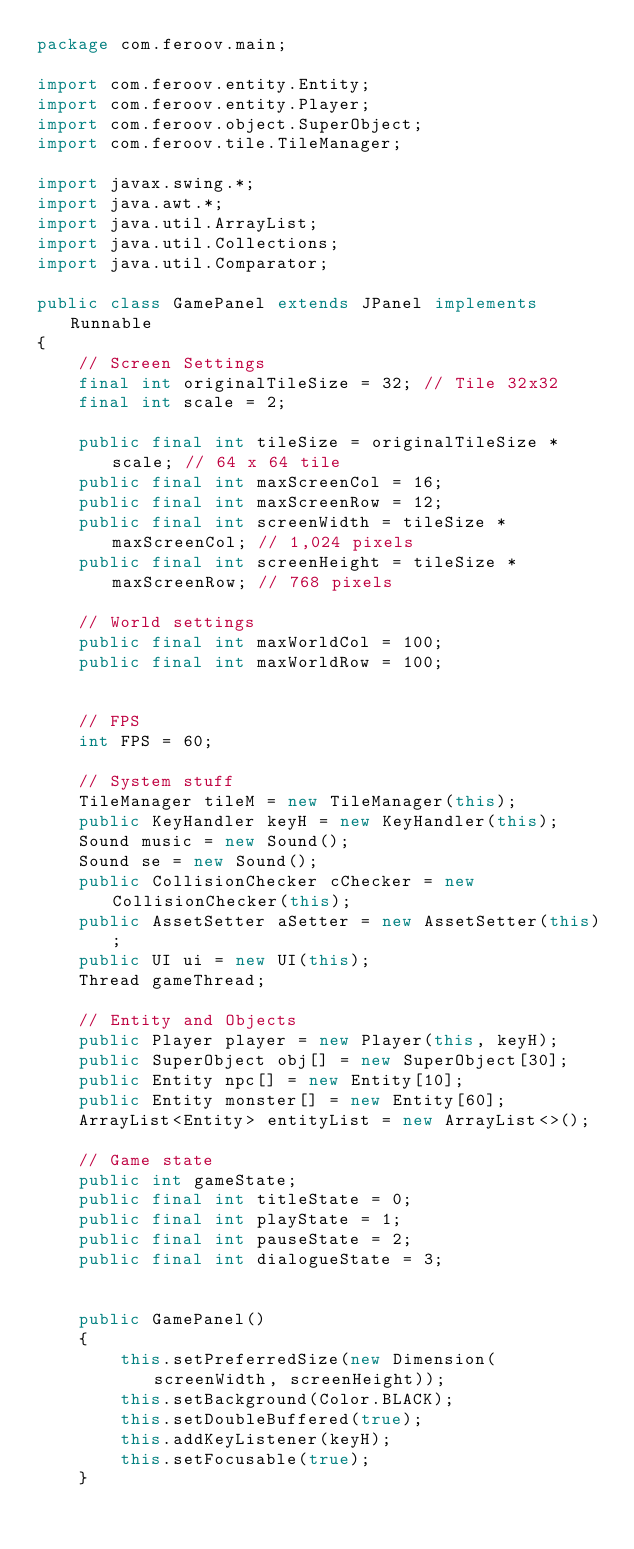Convert code to text. <code><loc_0><loc_0><loc_500><loc_500><_Java_>package com.feroov.main;

import com.feroov.entity.Entity;
import com.feroov.entity.Player;
import com.feroov.object.SuperObject;
import com.feroov.tile.TileManager;

import javax.swing.*;
import java.awt.*;
import java.util.ArrayList;
import java.util.Collections;
import java.util.Comparator;

public class GamePanel extends JPanel implements Runnable
{
    // Screen Settings
    final int originalTileSize = 32; // Tile 32x32
    final int scale = 2;

    public final int tileSize = originalTileSize * scale; // 64 x 64 tile
    public final int maxScreenCol = 16;
    public final int maxScreenRow = 12;
    public final int screenWidth = tileSize * maxScreenCol; // 1,024 pixels
    public final int screenHeight = tileSize * maxScreenRow; // 768 pixels

    // World settings
    public final int maxWorldCol = 100;
    public final int maxWorldRow = 100;


    // FPS
    int FPS = 60;

    // System stuff
    TileManager tileM = new TileManager(this);
    public KeyHandler keyH = new KeyHandler(this);
    Sound music = new Sound();
    Sound se = new Sound();
    public CollisionChecker cChecker = new CollisionChecker(this);
    public AssetSetter aSetter = new AssetSetter(this);
    public UI ui = new UI(this);
    Thread gameThread;

    // Entity and Objects
    public Player player = new Player(this, keyH);
    public SuperObject obj[] = new SuperObject[30];
    public Entity npc[] = new Entity[10];
    public Entity monster[] = new Entity[60];
    ArrayList<Entity> entityList = new ArrayList<>();

    // Game state
    public int gameState;
    public final int titleState = 0;
    public final int playState = 1;
    public final int pauseState = 2;
    public final int dialogueState = 3;


    public GamePanel()
    {
        this.setPreferredSize(new Dimension(screenWidth, screenHeight));
        this.setBackground(Color.BLACK);
        this.setDoubleBuffered(true);
        this.addKeyListener(keyH);
        this.setFocusable(true);
    }
</code> 